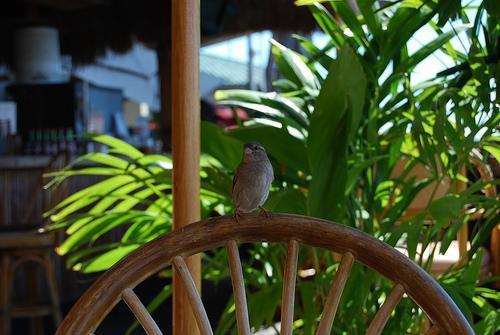How many chairs are visible?
Give a very brief answer. 3. 